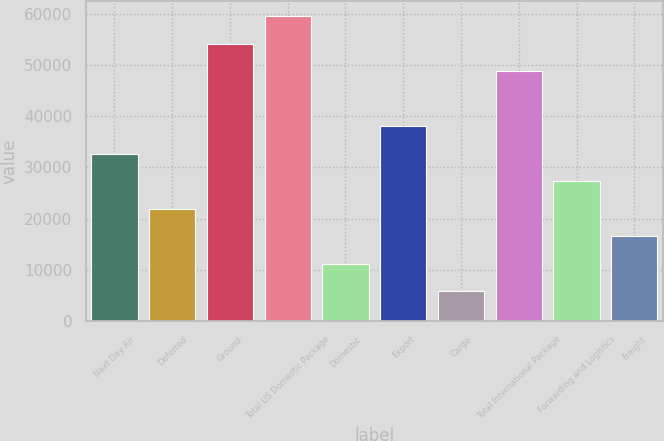<chart> <loc_0><loc_0><loc_500><loc_500><bar_chart><fcel>Next Day Air<fcel>Deferred<fcel>Ground<fcel>Total US Domestic Package<fcel>Domestic<fcel>Export<fcel>Cargo<fcel>Total International Package<fcel>Forwarding and Logistics<fcel>Freight<nl><fcel>32688.2<fcel>21968.8<fcel>54127<fcel>59486.7<fcel>11249.4<fcel>38047.9<fcel>5889.7<fcel>48767.3<fcel>27328.5<fcel>16609.1<nl></chart> 